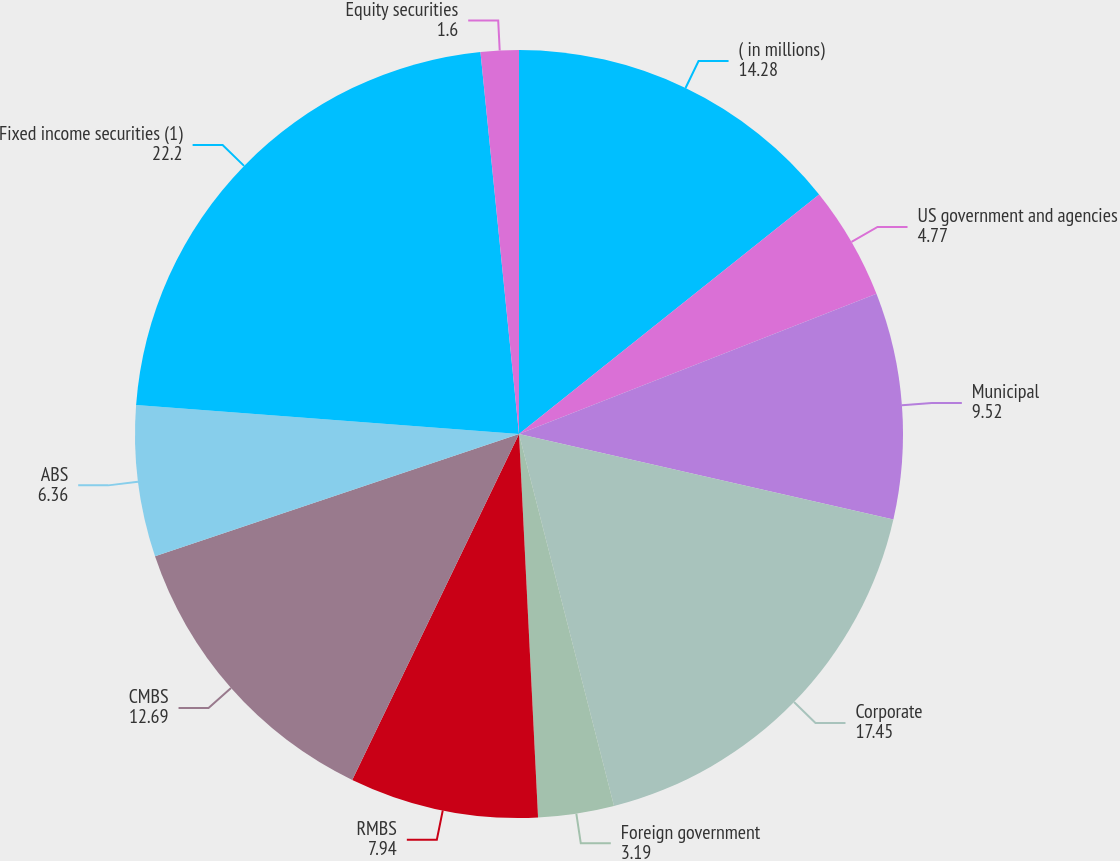Convert chart. <chart><loc_0><loc_0><loc_500><loc_500><pie_chart><fcel>( in millions)<fcel>US government and agencies<fcel>Municipal<fcel>Corporate<fcel>Foreign government<fcel>RMBS<fcel>CMBS<fcel>ABS<fcel>Fixed income securities (1)<fcel>Equity securities<nl><fcel>14.28%<fcel>4.77%<fcel>9.52%<fcel>17.45%<fcel>3.19%<fcel>7.94%<fcel>12.69%<fcel>6.36%<fcel>22.2%<fcel>1.6%<nl></chart> 